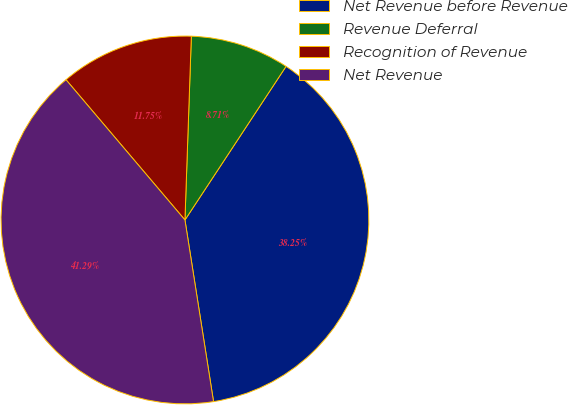Convert chart to OTSL. <chart><loc_0><loc_0><loc_500><loc_500><pie_chart><fcel>Net Revenue before Revenue<fcel>Revenue Deferral<fcel>Recognition of Revenue<fcel>Net Revenue<nl><fcel>38.25%<fcel>8.71%<fcel>11.75%<fcel>41.29%<nl></chart> 